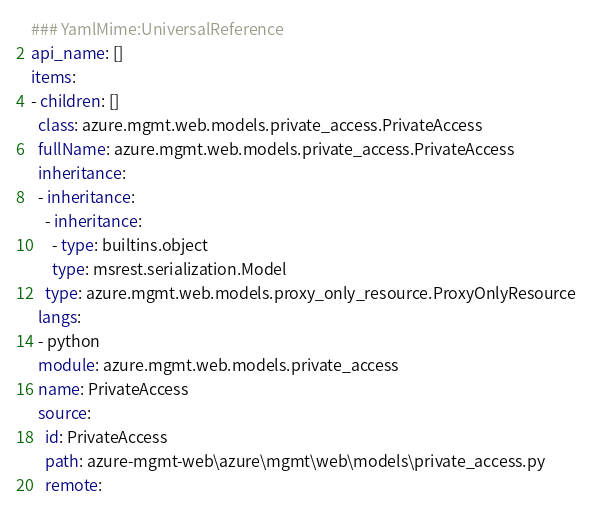<code> <loc_0><loc_0><loc_500><loc_500><_YAML_>### YamlMime:UniversalReference
api_name: []
items:
- children: []
  class: azure.mgmt.web.models.private_access.PrivateAccess
  fullName: azure.mgmt.web.models.private_access.PrivateAccess
  inheritance:
  - inheritance:
    - inheritance:
      - type: builtins.object
      type: msrest.serialization.Model
    type: azure.mgmt.web.models.proxy_only_resource.ProxyOnlyResource
  langs:
  - python
  module: azure.mgmt.web.models.private_access
  name: PrivateAccess
  source:
    id: PrivateAccess
    path: azure-mgmt-web\azure\mgmt\web\models\private_access.py
    remote:</code> 